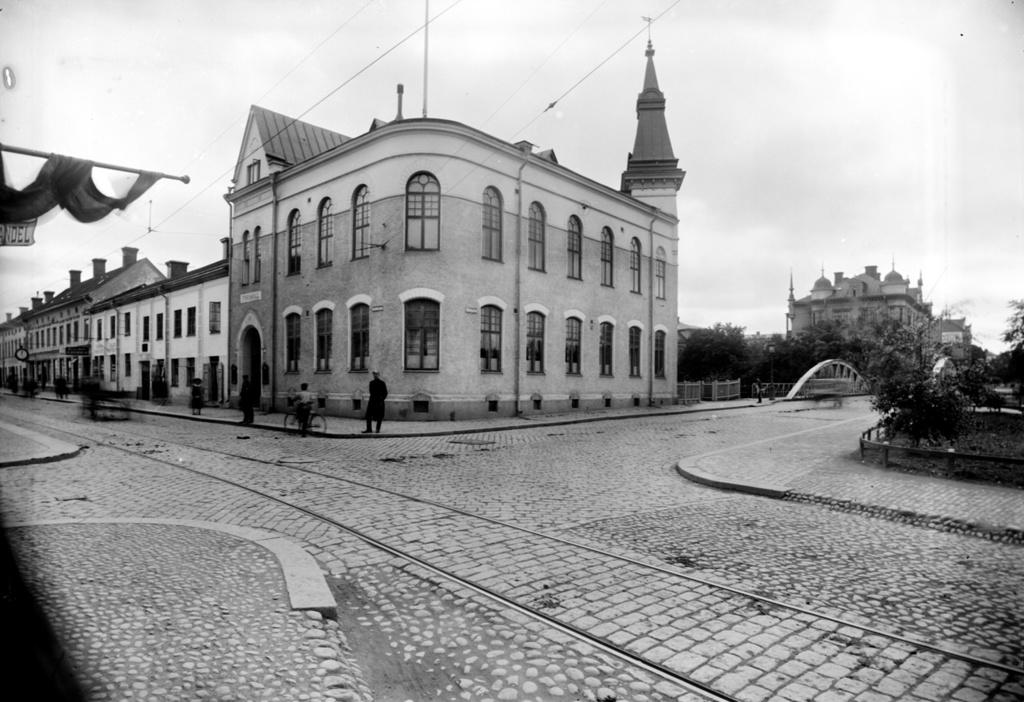What is the color scheme of the image? The image is black and white. What can be seen in the background of the image? There is sky, buildings, and trees visible in the background of the image. Are there any people in the image? Yes, there are persons in the image. What mode of transportation is present in the image? There is a bicycle in the image. What type of surface can be seen in the image? There is a road in the image. How many cakes are being carried by the persons in the image? There are no cakes visible in the image; it features a black and white scene with a bicycle, road, and persons. What type of branch is being used as a pipe in the image? There is no branch or pipe present in the image. 